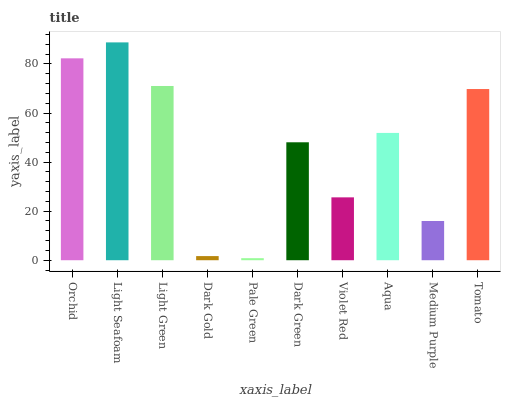Is Light Green the minimum?
Answer yes or no. No. Is Light Green the maximum?
Answer yes or no. No. Is Light Seafoam greater than Light Green?
Answer yes or no. Yes. Is Light Green less than Light Seafoam?
Answer yes or no. Yes. Is Light Green greater than Light Seafoam?
Answer yes or no. No. Is Light Seafoam less than Light Green?
Answer yes or no. No. Is Aqua the high median?
Answer yes or no. Yes. Is Dark Green the low median?
Answer yes or no. Yes. Is Orchid the high median?
Answer yes or no. No. Is Orchid the low median?
Answer yes or no. No. 